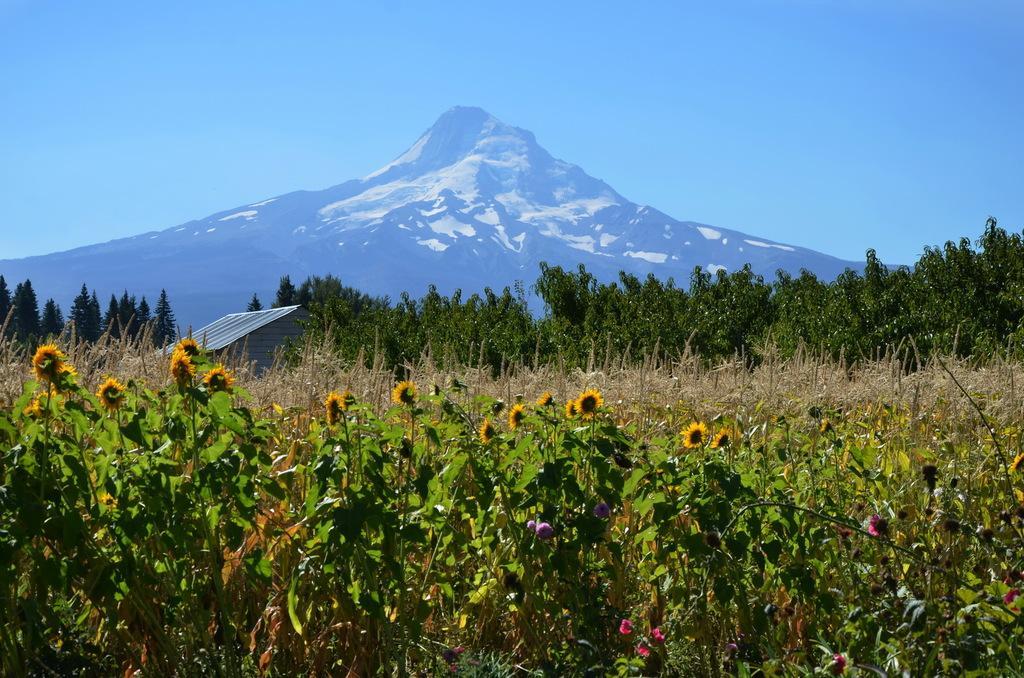Describe this image in one or two sentences. In this image there are plants, trees, flowers, mountains, a shed and the sky. 